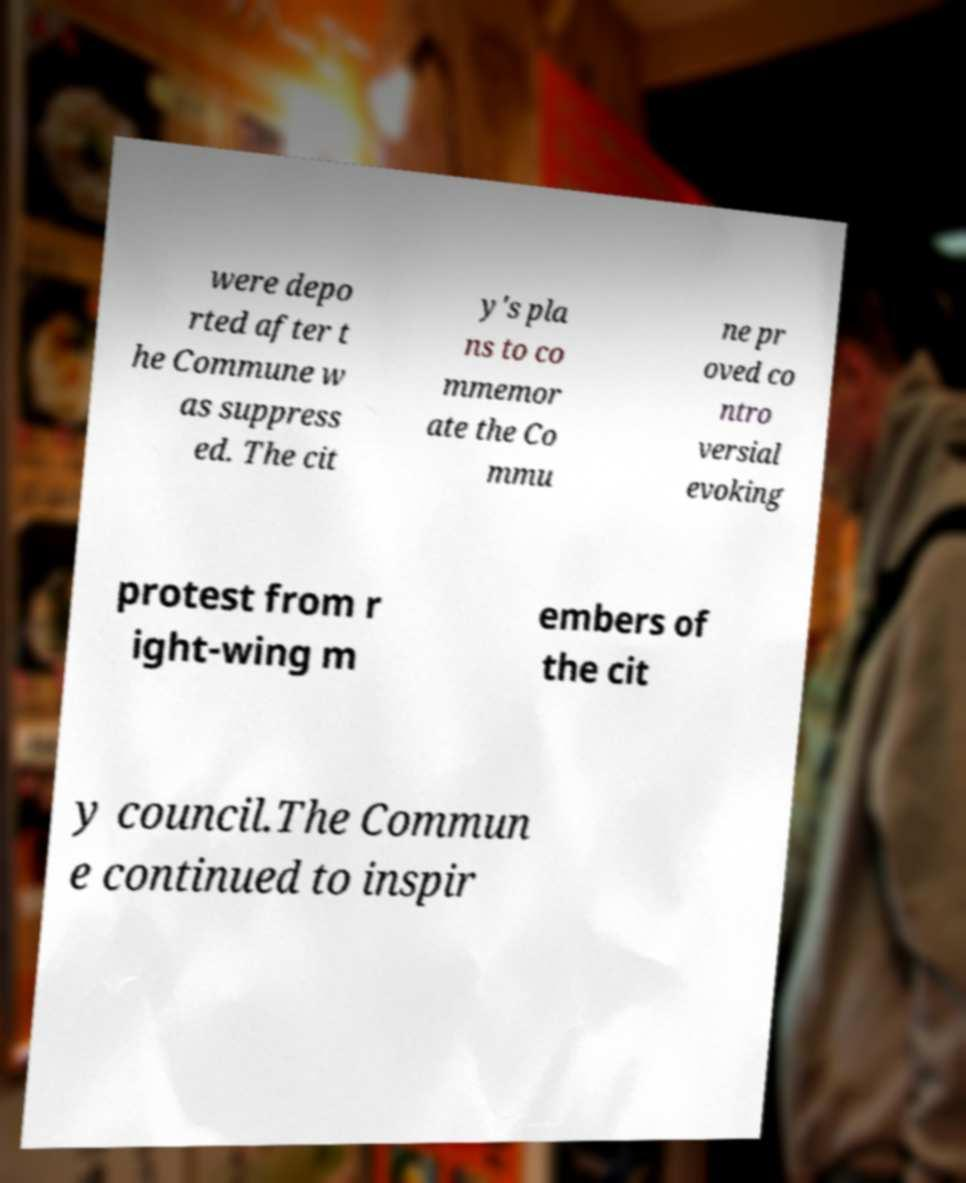Could you assist in decoding the text presented in this image and type it out clearly? were depo rted after t he Commune w as suppress ed. The cit y's pla ns to co mmemor ate the Co mmu ne pr oved co ntro versial evoking protest from r ight-wing m embers of the cit y council.The Commun e continued to inspir 